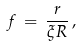Convert formula to latex. <formula><loc_0><loc_0><loc_500><loc_500>f \, = \, \frac { r } { \xi R } \, ,</formula> 